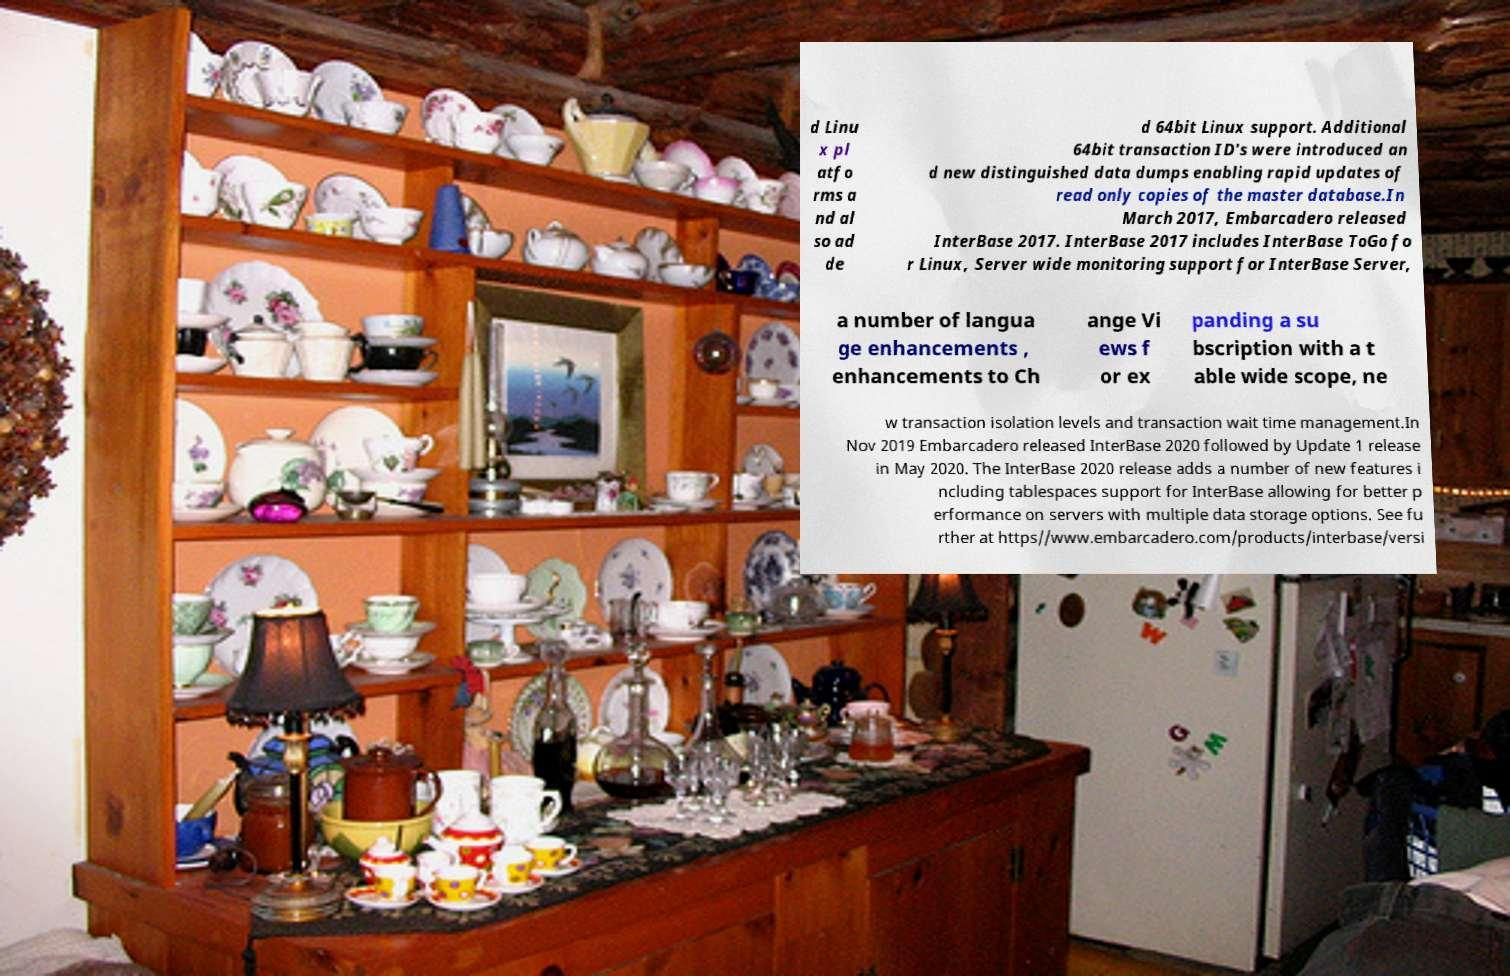For documentation purposes, I need the text within this image transcribed. Could you provide that? d Linu x pl atfo rms a nd al so ad de d 64bit Linux support. Additional 64bit transaction ID's were introduced an d new distinguished data dumps enabling rapid updates of read only copies of the master database.In March 2017, Embarcadero released InterBase 2017. InterBase 2017 includes InterBase ToGo fo r Linux, Server wide monitoring support for InterBase Server, a number of langua ge enhancements , enhancements to Ch ange Vi ews f or ex panding a su bscription with a t able wide scope, ne w transaction isolation levels and transaction wait time management.In Nov 2019 Embarcadero released InterBase 2020 followed by Update 1 release in May 2020. The InterBase 2020 release adds a number of new features i ncluding tablespaces support for InterBase allowing for better p erformance on servers with multiple data storage options. See fu rther at https//www.embarcadero.com/products/interbase/versi 